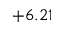Convert formula to latex. <formula><loc_0><loc_0><loc_500><loc_500>+ 6 . 2 1</formula> 